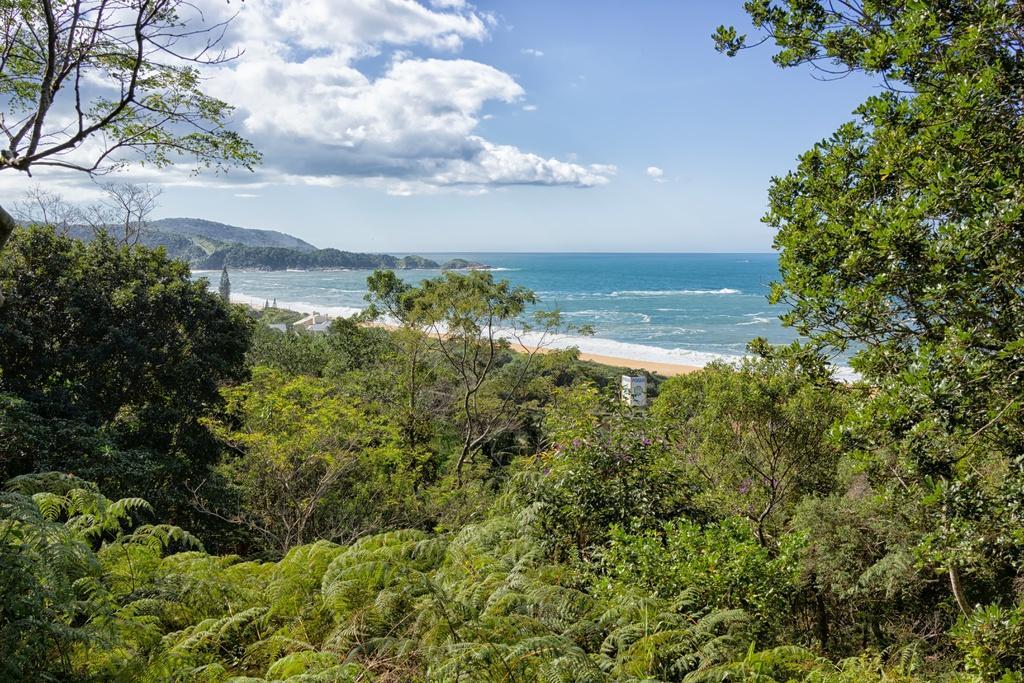Describe this image in one or two sentences. In this image in the foreground there are trees. In the background there are hills. The sky is cloudy. 